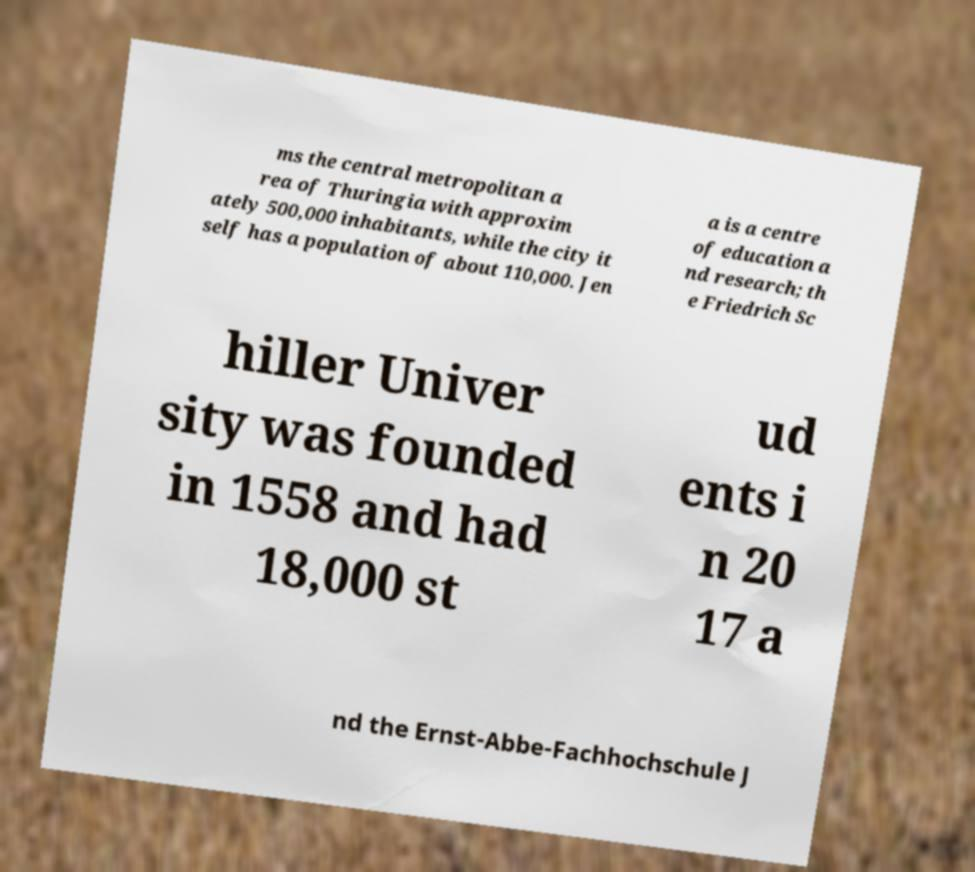There's text embedded in this image that I need extracted. Can you transcribe it verbatim? ms the central metropolitan a rea of Thuringia with approxim ately 500,000 inhabitants, while the city it self has a population of about 110,000. Jen a is a centre of education a nd research; th e Friedrich Sc hiller Univer sity was founded in 1558 and had 18,000 st ud ents i n 20 17 a nd the Ernst-Abbe-Fachhochschule J 